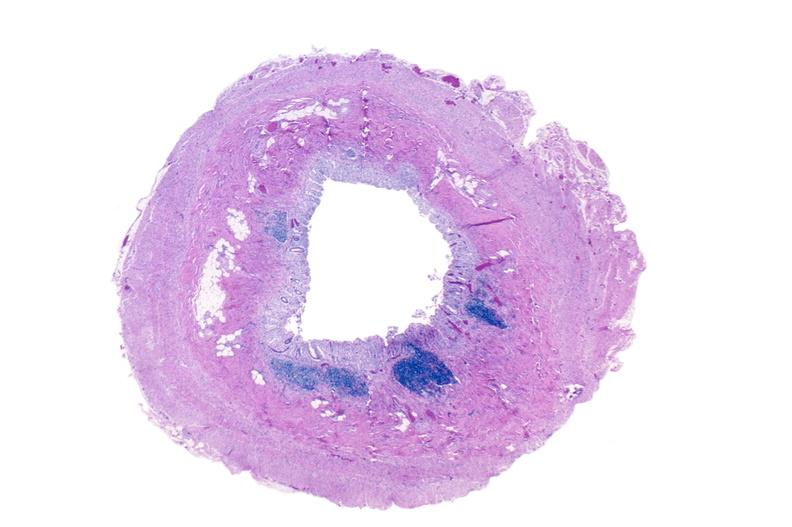does this image show normal appendix?
Answer the question using a single word or phrase. Yes 